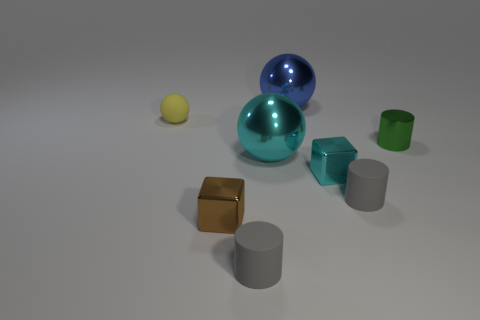What shape is the large thing that is in front of the yellow matte sphere?
Give a very brief answer. Sphere. There is a big metal sphere left of the big shiny ball that is behind the yellow matte object; what color is it?
Keep it short and to the point. Cyan. How many objects are rubber objects behind the small brown block or small blocks?
Your answer should be compact. 4. There is a cyan sphere; is it the same size as the blue metallic sphere on the right side of the tiny brown thing?
Your response must be concise. Yes. How many large things are either cyan blocks or yellow matte spheres?
Make the answer very short. 0. What shape is the blue thing?
Your answer should be very brief. Sphere. Is there a sphere made of the same material as the brown object?
Your response must be concise. Yes. Is the number of tiny brown matte blocks greater than the number of yellow matte things?
Keep it short and to the point. No. Is the brown cube made of the same material as the tiny sphere?
Provide a succinct answer. No. What number of rubber objects are either large blue balls or tiny gray cylinders?
Offer a terse response. 2. 